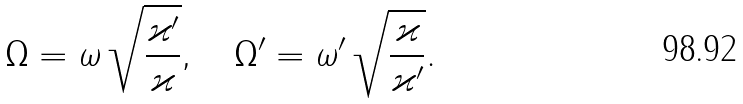<formula> <loc_0><loc_0><loc_500><loc_500>\Omega = \omega \, \sqrt { \frac { \varkappa ^ { \prime } } { \varkappa } } , \quad \Omega ^ { \prime } = \omega ^ { \prime } \, \sqrt { \frac { \varkappa } { \varkappa ^ { \prime } } } .</formula> 